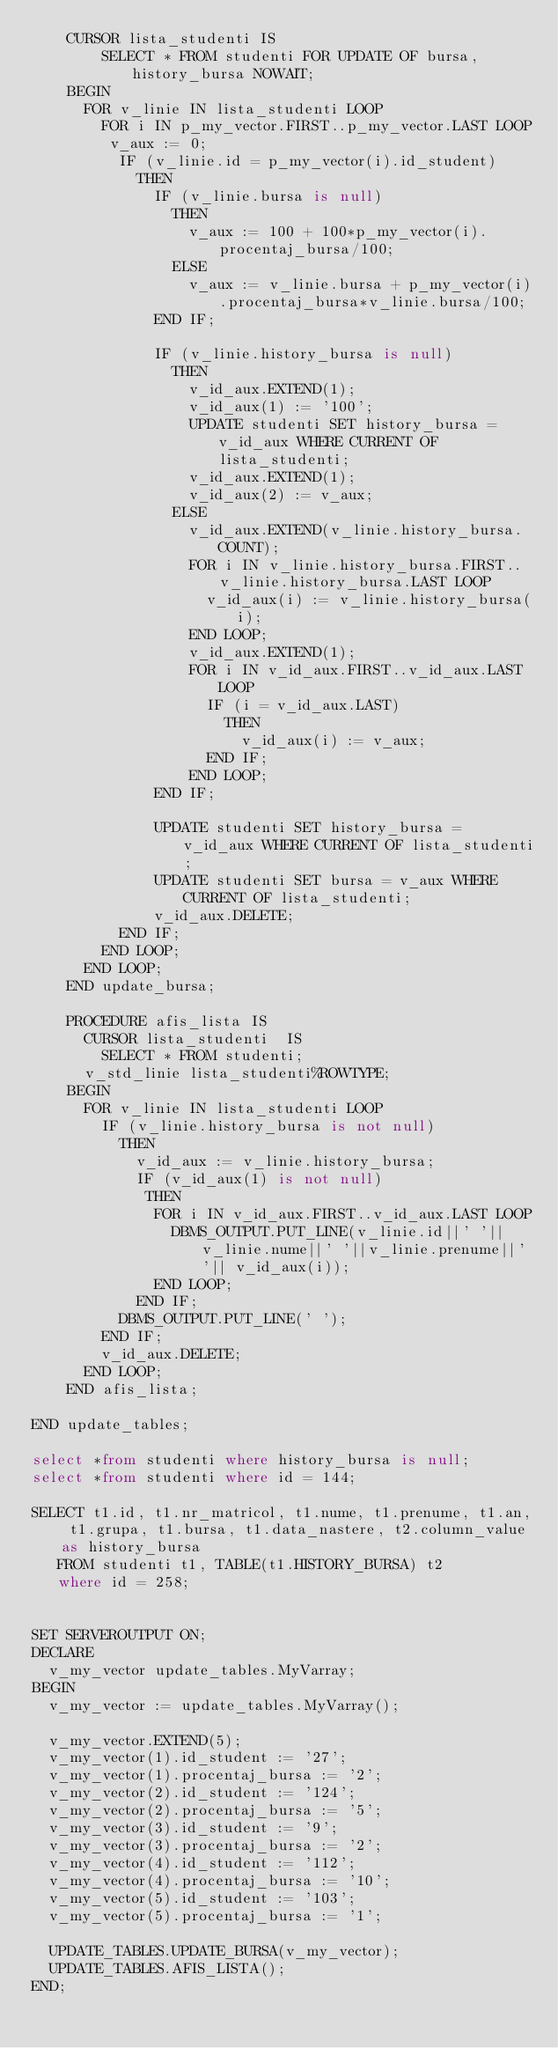<code> <loc_0><loc_0><loc_500><loc_500><_SQL_>    CURSOR lista_studenti IS
        SELECT * FROM studenti FOR UPDATE OF bursa,history_bursa NOWAIT;
    BEGIN
      FOR v_linie IN lista_studenti LOOP
        FOR i IN p_my_vector.FIRST..p_my_vector.LAST LOOP
         v_aux := 0;
          IF (v_linie.id = p_my_vector(i).id_student) 
            THEN
              IF (v_linie.bursa is null)
                THEN
                  v_aux := 100 + 100*p_my_vector(i).procentaj_bursa/100;
                ELSE
                  v_aux := v_linie.bursa + p_my_vector(i).procentaj_bursa*v_linie.bursa/100;
              END IF;
              
              IF (v_linie.history_bursa is null)
                THEN
                  v_id_aux.EXTEND(1);
                  v_id_aux(1) := '100';
                  UPDATE studenti SET history_bursa = v_id_aux WHERE CURRENT OF lista_studenti;
                  v_id_aux.EXTEND(1);
                  v_id_aux(2) := v_aux;
                ELSE
                  v_id_aux.EXTEND(v_linie.history_bursa.COUNT);
                  FOR i IN v_linie.history_bursa.FIRST..v_linie.history_bursa.LAST LOOP
                    v_id_aux(i) := v_linie.history_bursa(i);
                  END LOOP; 
                  v_id_aux.EXTEND(1);
                  FOR i IN v_id_aux.FIRST..v_id_aux.LAST LOOP
                    IF (i = v_id_aux.LAST)
                      THEN
                        v_id_aux(i) := v_aux;
                    END IF;
                  END LOOP; 
              END IF;
              
              UPDATE studenti SET history_bursa = v_id_aux WHERE CURRENT OF lista_studenti;
              UPDATE studenti SET bursa = v_aux WHERE CURRENT OF lista_studenti;
              v_id_aux.DELETE;
          END IF;
        END LOOP; 
      END LOOP;
    END update_bursa;
    
    PROCEDURE afis_lista IS 
      CURSOR lista_studenti  IS
        SELECT * FROM studenti;
      v_std_linie lista_studenti%ROWTYPE; 
    BEGIN
      FOR v_linie IN lista_studenti LOOP    
        IF (v_linie.history_bursa is not null)
          THEN
            v_id_aux := v_linie.history_bursa;
            IF (v_id_aux(1) is not null)
             THEN
              FOR i IN v_id_aux.FIRST..v_id_aux.LAST LOOP
                DBMS_OUTPUT.PUT_LINE(v_linie.id||' '||v_linie.nume||' '||v_linie.prenume||' '|| v_id_aux(i));
              END LOOP;
            END IF;
          DBMS_OUTPUT.PUT_LINE(' ');
        END IF;
        v_id_aux.DELETE;
      END LOOP; 
    END afis_lista;

END update_tables;

select *from studenti where history_bursa is null;
select *from studenti where id = 144;

SELECT t1.id, t1.nr_matricol, t1.nume, t1.prenume, t1.an, t1.grupa, t1.bursa, t1.data_nastere, t2.column_value as history_bursa
   FROM studenti t1, TABLE(t1.HISTORY_BURSA) t2
   where id = 258;


SET SERVEROUTPUT ON;
DECLARE
  v_my_vector update_tables.MyVarray;
BEGIN
  v_my_vector := update_tables.MyVarray();
  
  v_my_vector.EXTEND(5);
  v_my_vector(1).id_student := '27';
  v_my_vector(1).procentaj_bursa := '2';
  v_my_vector(2).id_student := '124';
  v_my_vector(2).procentaj_bursa := '5';
  v_my_vector(3).id_student := '9';
  v_my_vector(3).procentaj_bursa := '2';
  v_my_vector(4).id_student := '112';
  v_my_vector(4).procentaj_bursa := '10';
  v_my_vector(5).id_student := '103';
  v_my_vector(5).procentaj_bursa := '1';
  
  UPDATE_TABLES.UPDATE_BURSA(v_my_vector);
  UPDATE_TABLES.AFIS_LISTA();
END;
</code> 